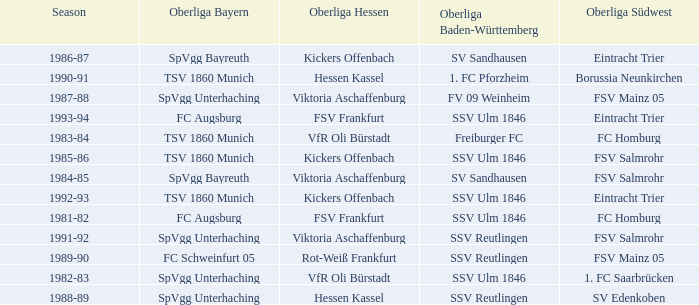Which oberliga südwes has an oberliga baden-württemberg of sv sandhausen in 1984-85? FSV Salmrohr. 